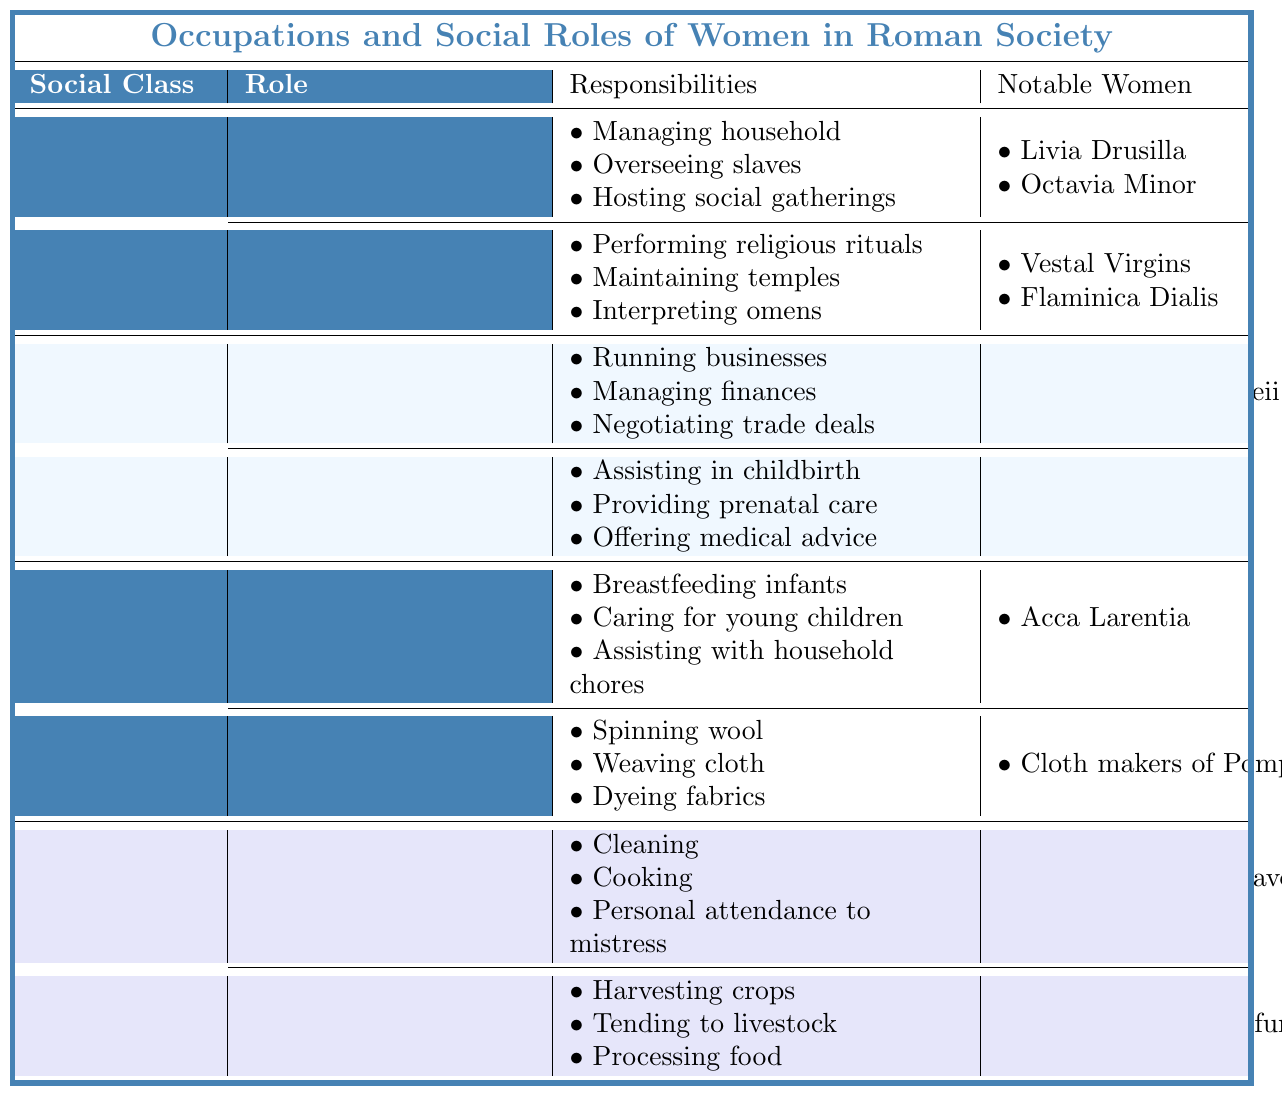What roles do upper-class women hold in Roman society? The table indicates that upper-class women can be Matrons and Priestesses, with specific responsibilities for each role.
Answer: Matron and Priestess Who is a notable woman associated with the role of Merchant in the middle class? From the table, Eumachia of Pompeii is listed under the Merchant role in the middle class.
Answer: Eumachia of Pompeii How many responsibilities does a Midwife have according to the table? The table shows that the Midwife role has three responsibilities: assisting in childbirth, providing prenatal care, and offering medical advice.
Answer: 3 Is Acca Larentia a notable woman in the Lower Class? Yes, Acca Larentia is noted alongside the Wet Nurse role in the Lower Class.
Answer: Yes What are the responsibilities of a Domestic Servant in the Slaves class? The table outlines three responsibilities of a Domestic Servant: cleaning, cooking, and providing personal attendance to their mistress.
Answer: Cleaning, cooking, personal attendance Which social class has a role associated with textile work? The Lower Class includes the Textile Worker role, which has responsibilities related to fabric making.
Answer: Lower Class Are there any notable women for the role of Agricultural Laborer? Yes, the table mentions Rural slaves on latifundia as notable women associated with the Agricultural Laborer role.
Answer: Yes How many roles are listed for women in the Middle Class? There are two roles listed for women in the Middle Class: Merchant and Midwife.
Answer: 2 Which role has closer responsibilities related to the family in the Lower Class? The Wet Nurse role has responsibilities related to caring for young children, which is closely associated with family care.
Answer: Wet Nurse What is the difference in the number of notable women between the Upper Class and Lower Class roles? The Upper Class has five notable women (counting the Priestess and Matron roles together), while the Lower Class has two notable women. Therefore, the difference is 5 - 2 = 3.
Answer: 3 